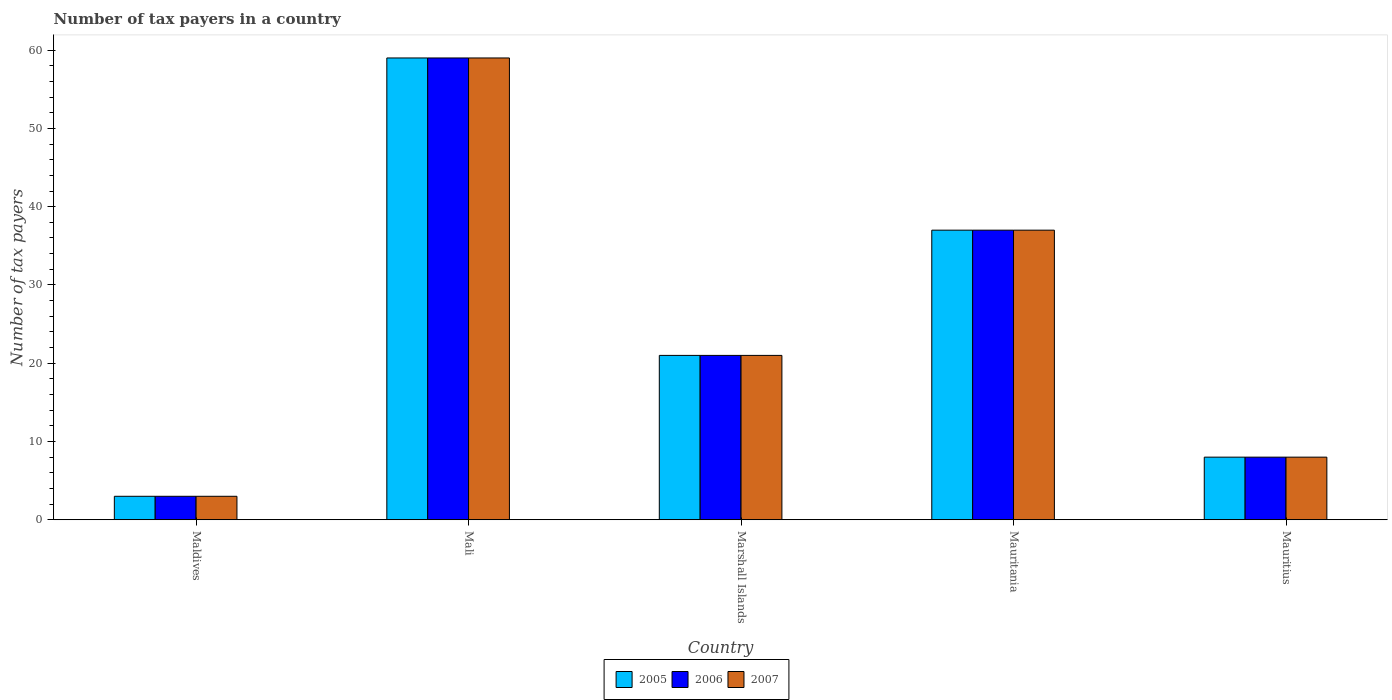Are the number of bars on each tick of the X-axis equal?
Provide a succinct answer. Yes. What is the label of the 2nd group of bars from the left?
Provide a succinct answer. Mali. In which country was the number of tax payers in in 2005 maximum?
Give a very brief answer. Mali. In which country was the number of tax payers in in 2005 minimum?
Offer a very short reply. Maldives. What is the total number of tax payers in in 2005 in the graph?
Your answer should be very brief. 128. What is the difference between the number of tax payers in in 2005 in Mauritania and that in Mauritius?
Your answer should be very brief. 29. What is the average number of tax payers in in 2006 per country?
Make the answer very short. 25.6. What is the difference between the number of tax payers in of/in 2005 and number of tax payers in of/in 2006 in Mali?
Your response must be concise. 0. What is the ratio of the number of tax payers in in 2007 in Maldives to that in Mali?
Offer a terse response. 0.05. Is the difference between the number of tax payers in in 2005 in Maldives and Mauritius greater than the difference between the number of tax payers in in 2006 in Maldives and Mauritius?
Provide a short and direct response. No. What is the difference between the highest and the second highest number of tax payers in in 2005?
Keep it short and to the point. -38. Is the sum of the number of tax payers in in 2007 in Mali and Mauritania greater than the maximum number of tax payers in in 2006 across all countries?
Offer a very short reply. Yes. What does the 3rd bar from the right in Marshall Islands represents?
Keep it short and to the point. 2005. Is it the case that in every country, the sum of the number of tax payers in in 2005 and number of tax payers in in 2007 is greater than the number of tax payers in in 2006?
Offer a terse response. Yes. How many countries are there in the graph?
Provide a succinct answer. 5. Does the graph contain grids?
Offer a terse response. No. What is the title of the graph?
Your response must be concise. Number of tax payers in a country. Does "1964" appear as one of the legend labels in the graph?
Ensure brevity in your answer.  No. What is the label or title of the X-axis?
Your response must be concise. Country. What is the label or title of the Y-axis?
Your response must be concise. Number of tax payers. What is the Number of tax payers in 2005 in Maldives?
Make the answer very short. 3. What is the Number of tax payers in 2006 in Maldives?
Your answer should be very brief. 3. What is the Number of tax payers of 2006 in Mali?
Ensure brevity in your answer.  59. What is the Number of tax payers of 2007 in Mali?
Make the answer very short. 59. What is the Number of tax payers of 2005 in Marshall Islands?
Ensure brevity in your answer.  21. What is the Number of tax payers of 2005 in Mauritania?
Your answer should be compact. 37. What is the Number of tax payers of 2006 in Mauritania?
Provide a succinct answer. 37. What is the Number of tax payers in 2007 in Mauritania?
Provide a short and direct response. 37. What is the Number of tax payers in 2005 in Mauritius?
Keep it short and to the point. 8. Across all countries, what is the maximum Number of tax payers in 2005?
Ensure brevity in your answer.  59. Across all countries, what is the maximum Number of tax payers in 2006?
Your answer should be very brief. 59. Across all countries, what is the maximum Number of tax payers in 2007?
Your response must be concise. 59. Across all countries, what is the minimum Number of tax payers in 2005?
Offer a very short reply. 3. What is the total Number of tax payers of 2005 in the graph?
Your response must be concise. 128. What is the total Number of tax payers in 2006 in the graph?
Give a very brief answer. 128. What is the total Number of tax payers in 2007 in the graph?
Offer a very short reply. 128. What is the difference between the Number of tax payers in 2005 in Maldives and that in Mali?
Offer a terse response. -56. What is the difference between the Number of tax payers in 2006 in Maldives and that in Mali?
Provide a short and direct response. -56. What is the difference between the Number of tax payers in 2007 in Maldives and that in Mali?
Keep it short and to the point. -56. What is the difference between the Number of tax payers of 2005 in Maldives and that in Marshall Islands?
Give a very brief answer. -18. What is the difference between the Number of tax payers in 2006 in Maldives and that in Marshall Islands?
Give a very brief answer. -18. What is the difference between the Number of tax payers of 2007 in Maldives and that in Marshall Islands?
Your answer should be compact. -18. What is the difference between the Number of tax payers of 2005 in Maldives and that in Mauritania?
Give a very brief answer. -34. What is the difference between the Number of tax payers in 2006 in Maldives and that in Mauritania?
Ensure brevity in your answer.  -34. What is the difference between the Number of tax payers in 2007 in Maldives and that in Mauritania?
Provide a succinct answer. -34. What is the difference between the Number of tax payers in 2006 in Maldives and that in Mauritius?
Give a very brief answer. -5. What is the difference between the Number of tax payers of 2006 in Mali and that in Marshall Islands?
Your answer should be compact. 38. What is the difference between the Number of tax payers in 2007 in Mali and that in Marshall Islands?
Keep it short and to the point. 38. What is the difference between the Number of tax payers in 2007 in Mali and that in Mauritius?
Offer a very short reply. 51. What is the difference between the Number of tax payers of 2006 in Marshall Islands and that in Mauritania?
Your answer should be compact. -16. What is the difference between the Number of tax payers in 2005 in Mauritania and that in Mauritius?
Offer a terse response. 29. What is the difference between the Number of tax payers of 2006 in Mauritania and that in Mauritius?
Your answer should be compact. 29. What is the difference between the Number of tax payers of 2005 in Maldives and the Number of tax payers of 2006 in Mali?
Your answer should be very brief. -56. What is the difference between the Number of tax payers of 2005 in Maldives and the Number of tax payers of 2007 in Mali?
Make the answer very short. -56. What is the difference between the Number of tax payers in 2006 in Maldives and the Number of tax payers in 2007 in Mali?
Offer a very short reply. -56. What is the difference between the Number of tax payers of 2005 in Maldives and the Number of tax payers of 2006 in Marshall Islands?
Offer a terse response. -18. What is the difference between the Number of tax payers of 2005 in Maldives and the Number of tax payers of 2007 in Marshall Islands?
Offer a terse response. -18. What is the difference between the Number of tax payers of 2005 in Maldives and the Number of tax payers of 2006 in Mauritania?
Your response must be concise. -34. What is the difference between the Number of tax payers in 2005 in Maldives and the Number of tax payers in 2007 in Mauritania?
Keep it short and to the point. -34. What is the difference between the Number of tax payers of 2006 in Maldives and the Number of tax payers of 2007 in Mauritania?
Offer a very short reply. -34. What is the difference between the Number of tax payers of 2005 in Maldives and the Number of tax payers of 2006 in Mauritius?
Offer a very short reply. -5. What is the difference between the Number of tax payers in 2005 in Maldives and the Number of tax payers in 2007 in Mauritius?
Provide a short and direct response. -5. What is the difference between the Number of tax payers in 2005 in Mali and the Number of tax payers in 2006 in Marshall Islands?
Your answer should be very brief. 38. What is the difference between the Number of tax payers in 2005 in Mali and the Number of tax payers in 2006 in Mauritius?
Provide a succinct answer. 51. What is the difference between the Number of tax payers of 2005 in Mali and the Number of tax payers of 2007 in Mauritius?
Your answer should be compact. 51. What is the difference between the Number of tax payers of 2005 in Marshall Islands and the Number of tax payers of 2007 in Mauritania?
Your answer should be compact. -16. What is the average Number of tax payers in 2005 per country?
Make the answer very short. 25.6. What is the average Number of tax payers in 2006 per country?
Ensure brevity in your answer.  25.6. What is the average Number of tax payers in 2007 per country?
Give a very brief answer. 25.6. What is the difference between the Number of tax payers of 2006 and Number of tax payers of 2007 in Maldives?
Give a very brief answer. 0. What is the difference between the Number of tax payers in 2005 and Number of tax payers in 2006 in Mali?
Ensure brevity in your answer.  0. What is the difference between the Number of tax payers of 2005 and Number of tax payers of 2007 in Mali?
Provide a short and direct response. 0. What is the difference between the Number of tax payers of 2006 and Number of tax payers of 2007 in Mali?
Make the answer very short. 0. What is the difference between the Number of tax payers of 2006 and Number of tax payers of 2007 in Marshall Islands?
Provide a short and direct response. 0. What is the difference between the Number of tax payers of 2005 and Number of tax payers of 2006 in Mauritania?
Provide a short and direct response. 0. What is the difference between the Number of tax payers of 2006 and Number of tax payers of 2007 in Mauritania?
Your response must be concise. 0. What is the difference between the Number of tax payers of 2005 and Number of tax payers of 2006 in Mauritius?
Ensure brevity in your answer.  0. What is the difference between the Number of tax payers in 2006 and Number of tax payers in 2007 in Mauritius?
Your answer should be very brief. 0. What is the ratio of the Number of tax payers of 2005 in Maldives to that in Mali?
Provide a succinct answer. 0.05. What is the ratio of the Number of tax payers of 2006 in Maldives to that in Mali?
Provide a succinct answer. 0.05. What is the ratio of the Number of tax payers in 2007 in Maldives to that in Mali?
Give a very brief answer. 0.05. What is the ratio of the Number of tax payers of 2005 in Maldives to that in Marshall Islands?
Provide a short and direct response. 0.14. What is the ratio of the Number of tax payers in 2006 in Maldives to that in Marshall Islands?
Offer a very short reply. 0.14. What is the ratio of the Number of tax payers in 2007 in Maldives to that in Marshall Islands?
Offer a very short reply. 0.14. What is the ratio of the Number of tax payers of 2005 in Maldives to that in Mauritania?
Offer a very short reply. 0.08. What is the ratio of the Number of tax payers in 2006 in Maldives to that in Mauritania?
Make the answer very short. 0.08. What is the ratio of the Number of tax payers in 2007 in Maldives to that in Mauritania?
Provide a succinct answer. 0.08. What is the ratio of the Number of tax payers of 2006 in Maldives to that in Mauritius?
Make the answer very short. 0.38. What is the ratio of the Number of tax payers in 2007 in Maldives to that in Mauritius?
Ensure brevity in your answer.  0.38. What is the ratio of the Number of tax payers of 2005 in Mali to that in Marshall Islands?
Offer a terse response. 2.81. What is the ratio of the Number of tax payers in 2006 in Mali to that in Marshall Islands?
Provide a succinct answer. 2.81. What is the ratio of the Number of tax payers of 2007 in Mali to that in Marshall Islands?
Give a very brief answer. 2.81. What is the ratio of the Number of tax payers in 2005 in Mali to that in Mauritania?
Ensure brevity in your answer.  1.59. What is the ratio of the Number of tax payers of 2006 in Mali to that in Mauritania?
Offer a terse response. 1.59. What is the ratio of the Number of tax payers of 2007 in Mali to that in Mauritania?
Provide a short and direct response. 1.59. What is the ratio of the Number of tax payers of 2005 in Mali to that in Mauritius?
Your response must be concise. 7.38. What is the ratio of the Number of tax payers of 2006 in Mali to that in Mauritius?
Your response must be concise. 7.38. What is the ratio of the Number of tax payers in 2007 in Mali to that in Mauritius?
Your response must be concise. 7.38. What is the ratio of the Number of tax payers in 2005 in Marshall Islands to that in Mauritania?
Offer a terse response. 0.57. What is the ratio of the Number of tax payers in 2006 in Marshall Islands to that in Mauritania?
Your answer should be very brief. 0.57. What is the ratio of the Number of tax payers of 2007 in Marshall Islands to that in Mauritania?
Ensure brevity in your answer.  0.57. What is the ratio of the Number of tax payers in 2005 in Marshall Islands to that in Mauritius?
Offer a very short reply. 2.62. What is the ratio of the Number of tax payers in 2006 in Marshall Islands to that in Mauritius?
Provide a short and direct response. 2.62. What is the ratio of the Number of tax payers in 2007 in Marshall Islands to that in Mauritius?
Ensure brevity in your answer.  2.62. What is the ratio of the Number of tax payers of 2005 in Mauritania to that in Mauritius?
Your response must be concise. 4.62. What is the ratio of the Number of tax payers of 2006 in Mauritania to that in Mauritius?
Provide a succinct answer. 4.62. What is the ratio of the Number of tax payers in 2007 in Mauritania to that in Mauritius?
Provide a short and direct response. 4.62. What is the difference between the highest and the second highest Number of tax payers of 2005?
Offer a very short reply. 22. What is the difference between the highest and the second highest Number of tax payers of 2006?
Give a very brief answer. 22. What is the difference between the highest and the second highest Number of tax payers in 2007?
Offer a terse response. 22. What is the difference between the highest and the lowest Number of tax payers of 2005?
Offer a terse response. 56. What is the difference between the highest and the lowest Number of tax payers of 2006?
Keep it short and to the point. 56. 